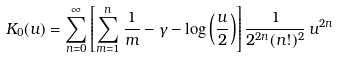Convert formula to latex. <formula><loc_0><loc_0><loc_500><loc_500>K _ { 0 } ( u ) = \sum _ { n = 0 } ^ { \infty } \left [ \sum _ { m = 1 } ^ { n } \frac { 1 } { m } - \gamma - \log \left ( \frac { u } { 2 } \right ) \right ] \frac { 1 } { 2 ^ { 2 n } ( n ! ) ^ { 2 } } \, u ^ { 2 n }</formula> 